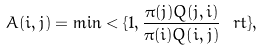Convert formula to latex. <formula><loc_0><loc_0><loc_500><loc_500>A ( i , j ) = \min < \{ 1 , \frac { \pi ( j ) Q ( j , i ) } { \pi ( i ) Q ( i , j ) } \ r t \} ,</formula> 